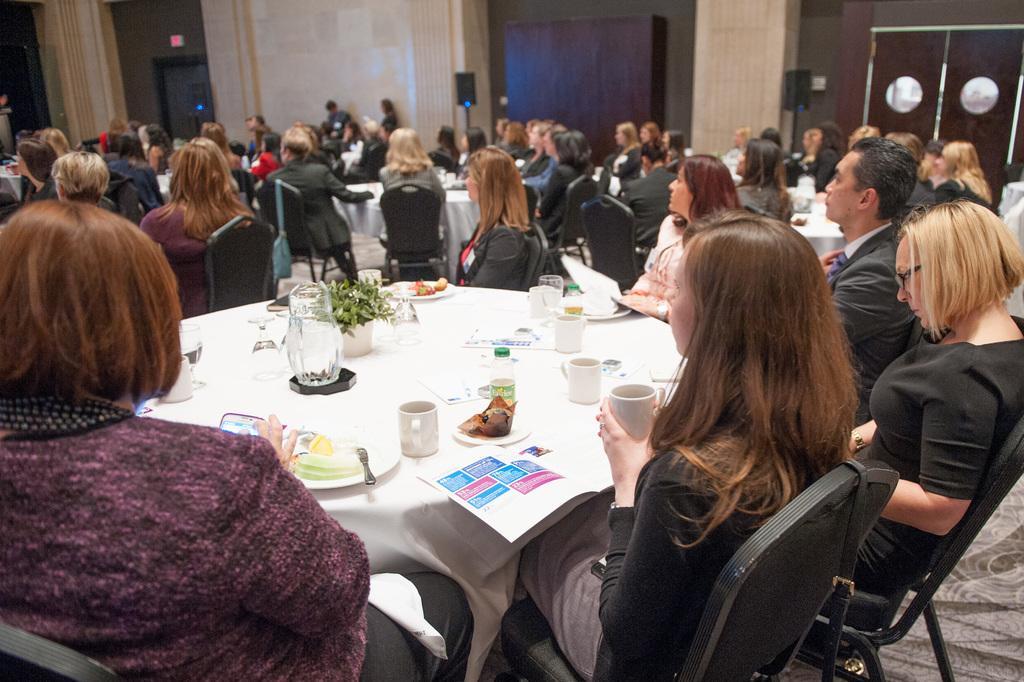Could you give a brief overview of what you see in this image? In this picture we can see group of people sitting on chairs and in front of them on table we have jar with water in it, flower pot with plant in it, plate with food item in it, cups, bottles, glasses , book, papers and in background we can see wall, speakers, door. 